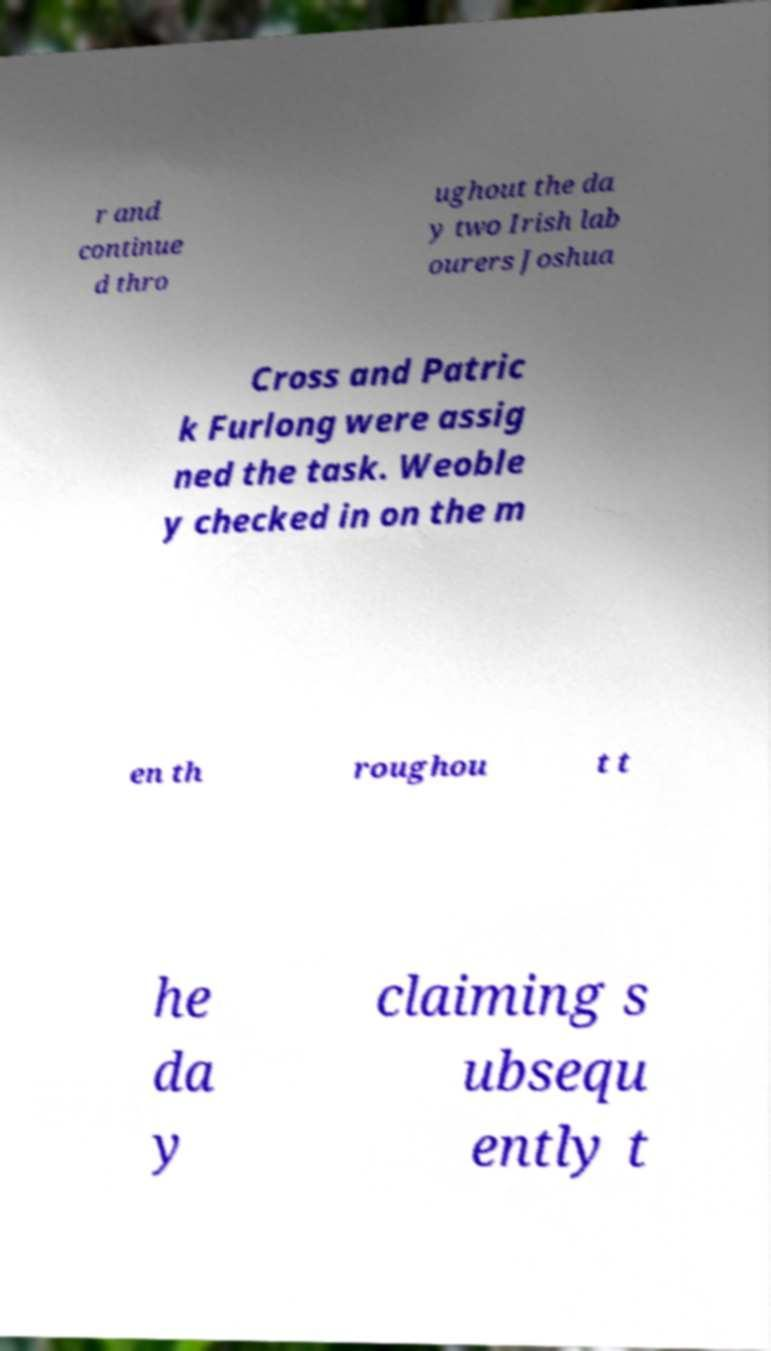I need the written content from this picture converted into text. Can you do that? r and continue d thro ughout the da y two Irish lab ourers Joshua Cross and Patric k Furlong were assig ned the task. Weoble y checked in on the m en th roughou t t he da y claiming s ubsequ ently t 